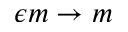<formula> <loc_0><loc_0><loc_500><loc_500>\epsilon m \rightarrow m</formula> 